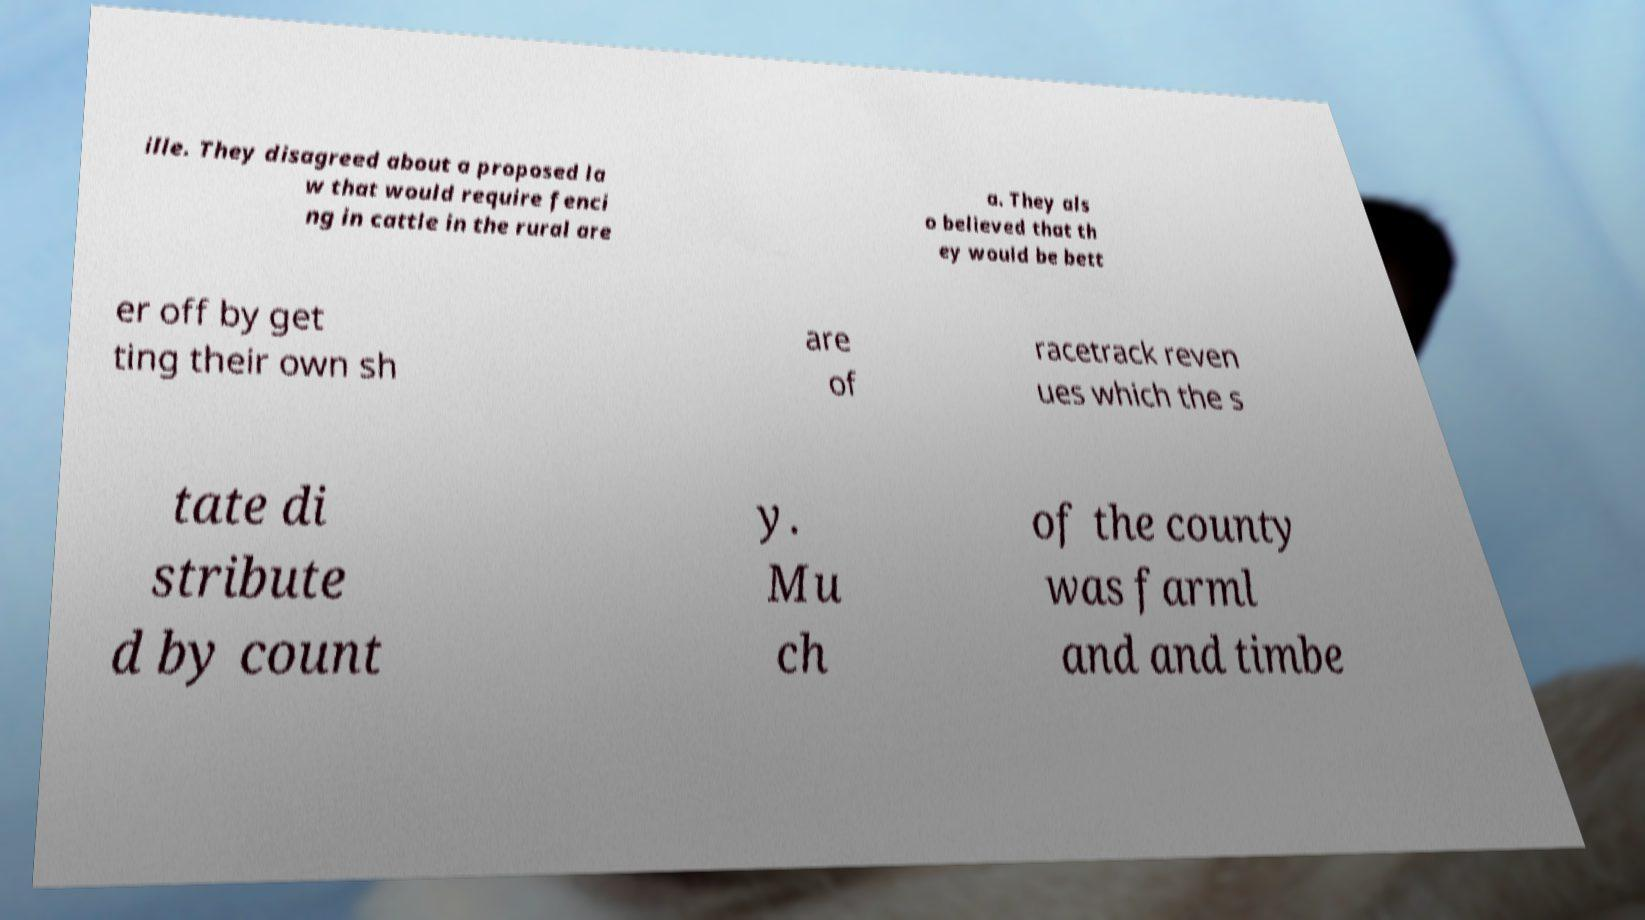For documentation purposes, I need the text within this image transcribed. Could you provide that? ille. They disagreed about a proposed la w that would require fenci ng in cattle in the rural are a. They als o believed that th ey would be bett er off by get ting their own sh are of racetrack reven ues which the s tate di stribute d by count y. Mu ch of the county was farml and and timbe 